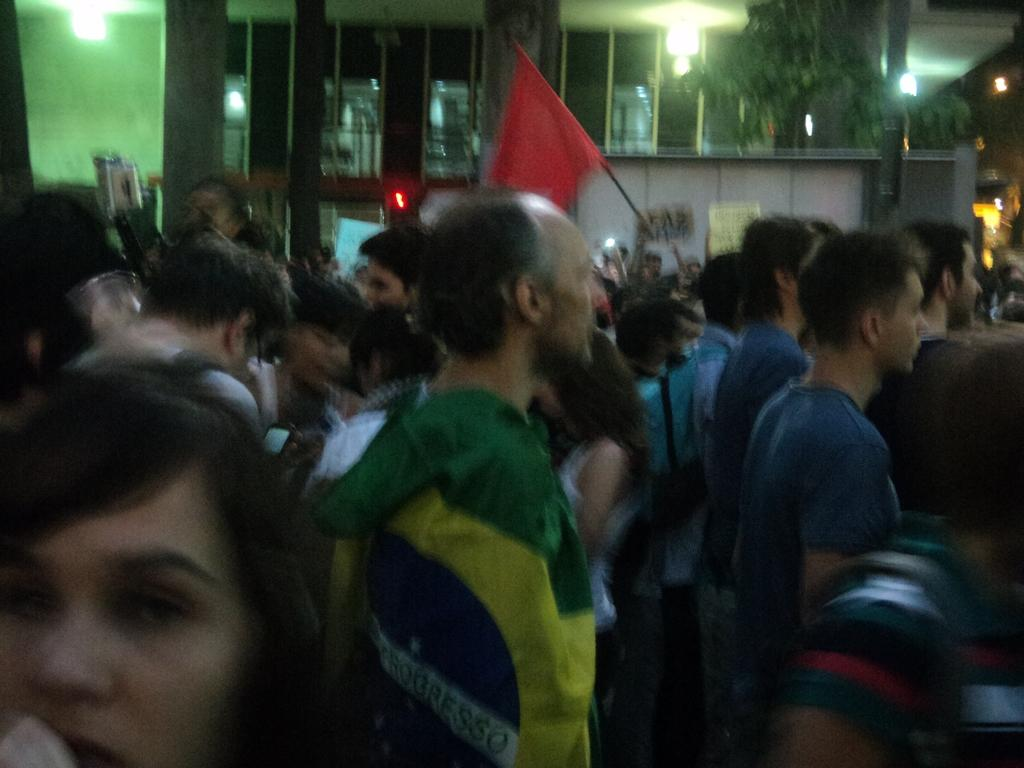What is the main focus of the image? There is a group of people in the center of the image. What can be seen in the background of the image? There is a building, lights, a tree, a pole, boards, a wall, windows, and a roof visible in the background of the image. Can you describe the setting of the image? The image appears to be set in an urban environment, with a group of people in the foreground and various structures and elements in the background. What suggestion does the town make to the people in the image? There is no town present in the image, nor is there any indication of a suggestion being made. 